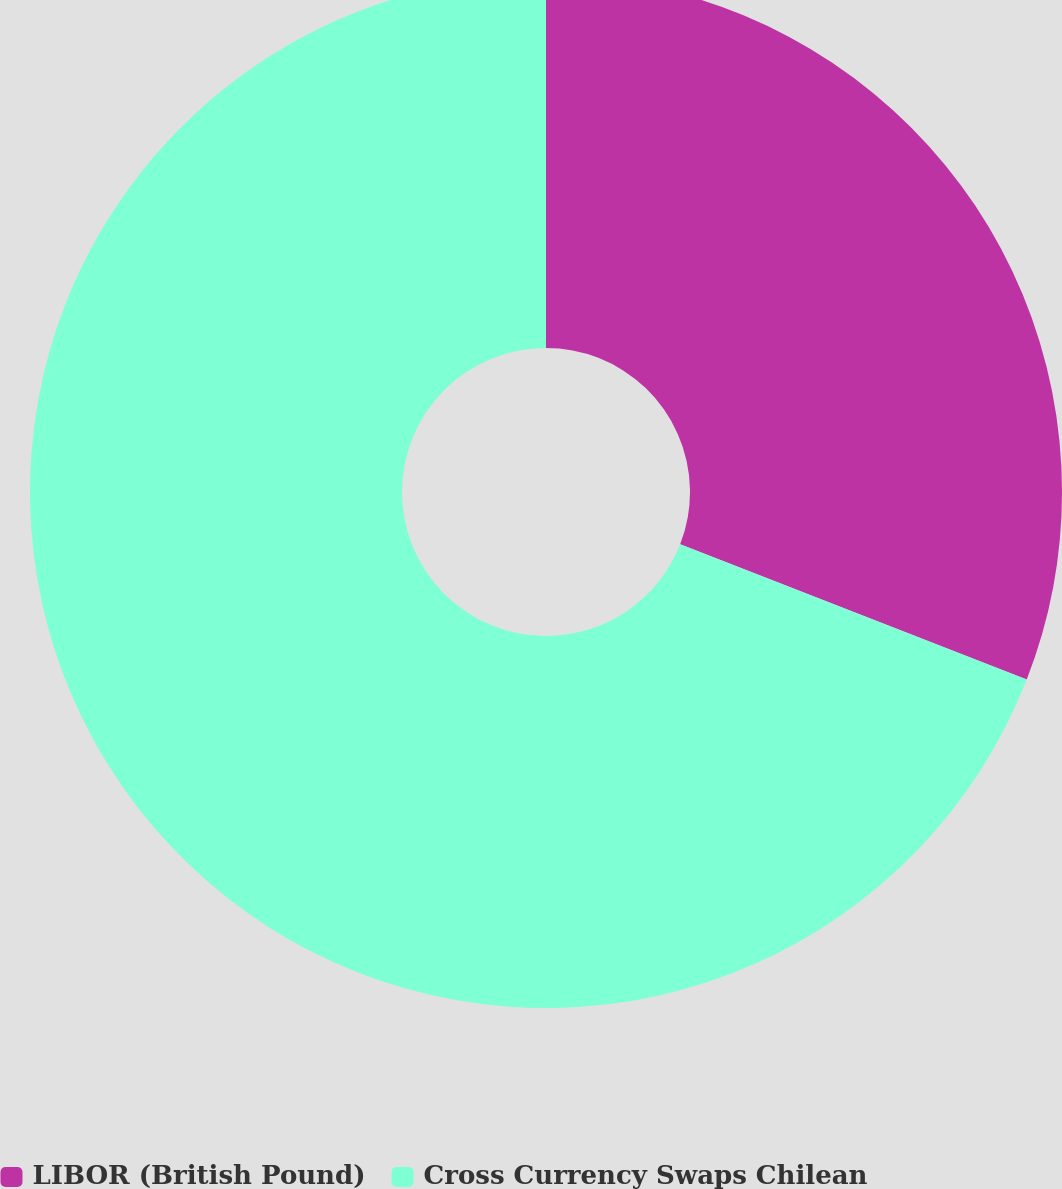<chart> <loc_0><loc_0><loc_500><loc_500><pie_chart><fcel>LIBOR (British Pound)<fcel>Cross Currency Swaps Chilean<nl><fcel>30.92%<fcel>69.08%<nl></chart> 